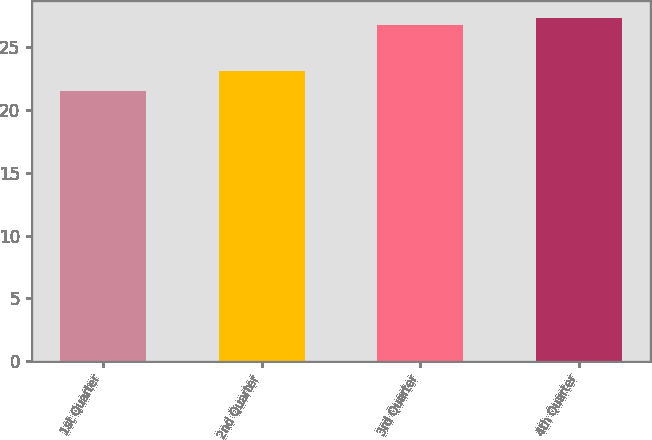<chart> <loc_0><loc_0><loc_500><loc_500><bar_chart><fcel>1st Quarter<fcel>2nd Quarter<fcel>3rd Quarter<fcel>4th Quarter<nl><fcel>21.56<fcel>23.1<fcel>26.79<fcel>27.32<nl></chart> 